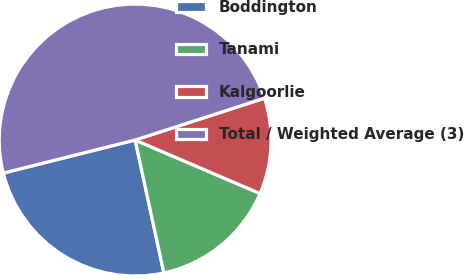Convert chart. <chart><loc_0><loc_0><loc_500><loc_500><pie_chart><fcel>Boddington<fcel>Tanami<fcel>Kalgoorlie<fcel>Total / Weighted Average (3)<nl><fcel>24.48%<fcel>15.17%<fcel>11.42%<fcel>48.93%<nl></chart> 